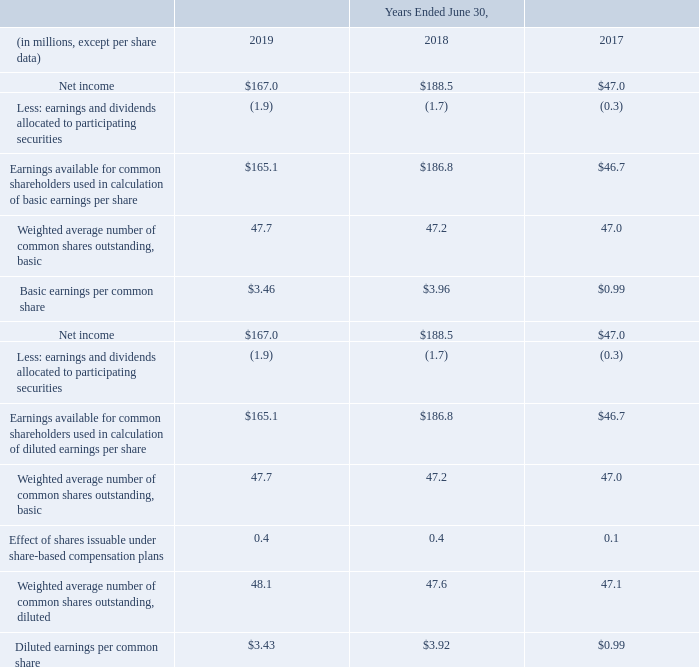5. Earnings per Common Share
The calculations of basic and diluted earnings per common share for the years ended June 30, 2019, 2018 and 2017 were as follows:
What was the Diluted earnings per common share in 2019? $3.43. What was the Basic earnings per common share in 2018? $3.96. In which years is the diluted earnings per common share calculated? 2019, 2018, 2017. In which year was the Weighted average number of common shares outstanding, basic largest? 47.7>47.2>47.0
Answer: 2019. What was the change in Weighted average number of common shares outstanding, basic in 2019 from 2018?
Answer scale should be: million. 47.7-47.2
Answer: 0.5. What was the percentage change in Weighted average number of common shares outstanding, basic in 2019 from 2018?
Answer scale should be: percent. (47.7-47.2)/47.2
Answer: 1.06. 